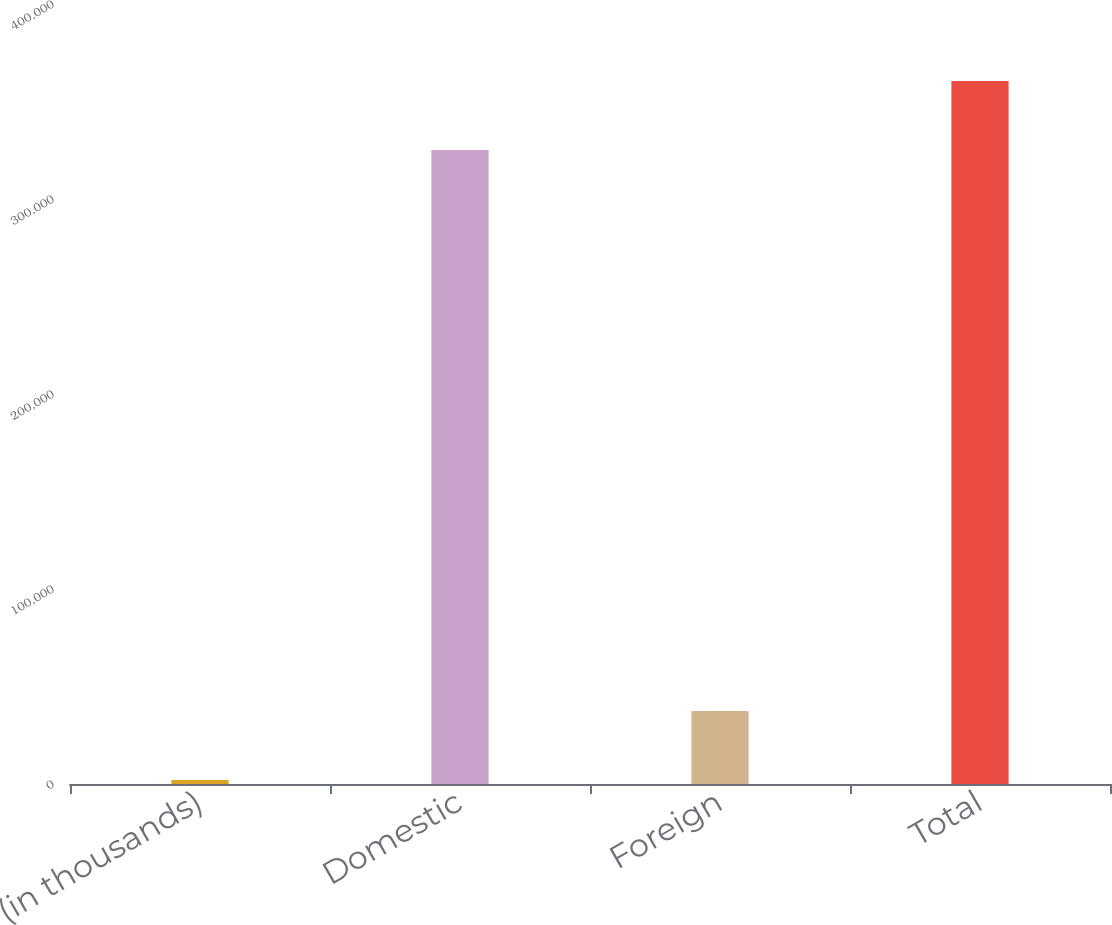Convert chart to OTSL. <chart><loc_0><loc_0><loc_500><loc_500><bar_chart><fcel>(in thousands)<fcel>Domestic<fcel>Foreign<fcel>Total<nl><fcel>2015<fcel>325097<fcel>37490<fcel>360572<nl></chart> 